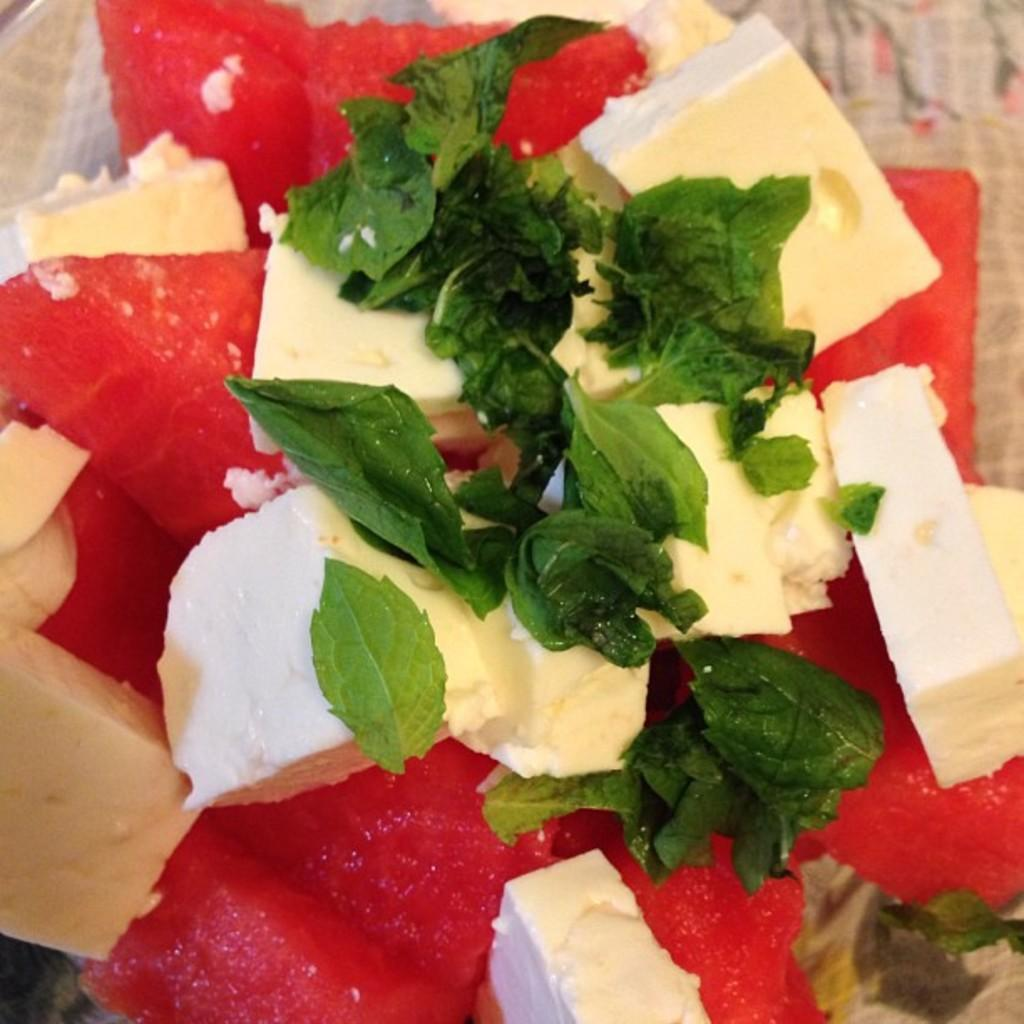What types of items can be seen on the plate in the image? There are food items and leaves placed on a plate in the image. Can you describe the food items in the image? Unfortunately, the specific food items cannot be identified from the provided facts. What is the purpose of the leaves in the image? The purpose of the leaves in the image is not clear from the provided facts. How does the team show respect for the adjustment in the image? There is no team, respect, or adjustment present in the image; it only features food items and leaves placed on a plate. 